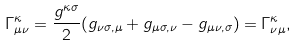Convert formula to latex. <formula><loc_0><loc_0><loc_500><loc_500>\Gamma _ { \mu \nu } ^ { \kappa } = \frac { g ^ { \kappa \sigma } } { 2 } ( g _ { \nu \sigma , \mu } + g _ { \mu \sigma , \nu } - g _ { \mu \nu , \sigma } ) = \Gamma _ { \nu \mu } ^ { \kappa } ,</formula> 